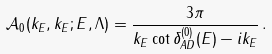<formula> <loc_0><loc_0><loc_500><loc_500>\mathcal { A } _ { 0 } ( k _ { E } , k _ { E } ; E , \Lambda ) = \frac { 3 \pi } { k _ { E } \cot \delta ^ { ( 0 ) } _ { A D } ( E ) - i k _ { E } } \, .</formula> 